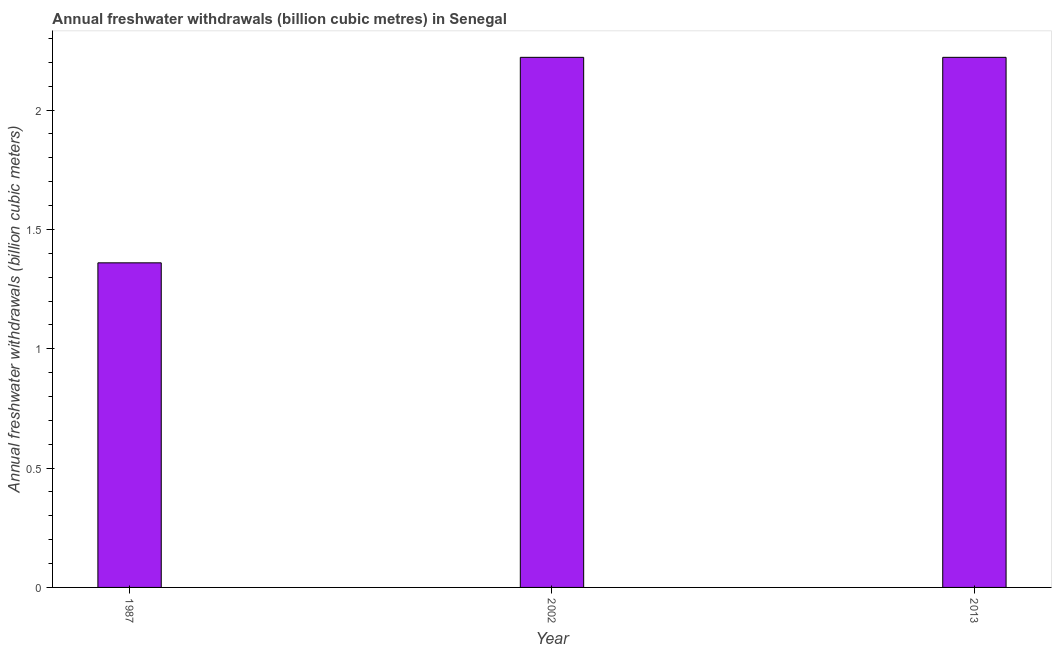What is the title of the graph?
Make the answer very short. Annual freshwater withdrawals (billion cubic metres) in Senegal. What is the label or title of the Y-axis?
Ensure brevity in your answer.  Annual freshwater withdrawals (billion cubic meters). What is the annual freshwater withdrawals in 2002?
Keep it short and to the point. 2.22. Across all years, what is the maximum annual freshwater withdrawals?
Provide a short and direct response. 2.22. Across all years, what is the minimum annual freshwater withdrawals?
Offer a very short reply. 1.36. In which year was the annual freshwater withdrawals maximum?
Make the answer very short. 2002. What is the sum of the annual freshwater withdrawals?
Make the answer very short. 5.8. What is the difference between the annual freshwater withdrawals in 1987 and 2002?
Ensure brevity in your answer.  -0.86. What is the average annual freshwater withdrawals per year?
Offer a terse response. 1.93. What is the median annual freshwater withdrawals?
Offer a terse response. 2.22. In how many years, is the annual freshwater withdrawals greater than 0.4 billion cubic meters?
Your answer should be very brief. 3. Do a majority of the years between 2002 and 2013 (inclusive) have annual freshwater withdrawals greater than 0.4 billion cubic meters?
Give a very brief answer. Yes. What is the ratio of the annual freshwater withdrawals in 1987 to that in 2002?
Your answer should be very brief. 0.61. Is the annual freshwater withdrawals in 1987 less than that in 2013?
Offer a terse response. Yes. What is the difference between the highest and the second highest annual freshwater withdrawals?
Provide a succinct answer. 0. Is the sum of the annual freshwater withdrawals in 1987 and 2013 greater than the maximum annual freshwater withdrawals across all years?
Provide a succinct answer. Yes. What is the difference between the highest and the lowest annual freshwater withdrawals?
Give a very brief answer. 0.86. In how many years, is the annual freshwater withdrawals greater than the average annual freshwater withdrawals taken over all years?
Your answer should be very brief. 2. How many bars are there?
Your answer should be compact. 3. Are all the bars in the graph horizontal?
Offer a very short reply. No. What is the Annual freshwater withdrawals (billion cubic meters) of 1987?
Your answer should be compact. 1.36. What is the Annual freshwater withdrawals (billion cubic meters) in 2002?
Offer a terse response. 2.22. What is the Annual freshwater withdrawals (billion cubic meters) of 2013?
Provide a succinct answer. 2.22. What is the difference between the Annual freshwater withdrawals (billion cubic meters) in 1987 and 2002?
Offer a very short reply. -0.86. What is the difference between the Annual freshwater withdrawals (billion cubic meters) in 1987 and 2013?
Keep it short and to the point. -0.86. What is the difference between the Annual freshwater withdrawals (billion cubic meters) in 2002 and 2013?
Your response must be concise. 0. What is the ratio of the Annual freshwater withdrawals (billion cubic meters) in 1987 to that in 2002?
Your answer should be compact. 0.61. What is the ratio of the Annual freshwater withdrawals (billion cubic meters) in 1987 to that in 2013?
Your response must be concise. 0.61. 